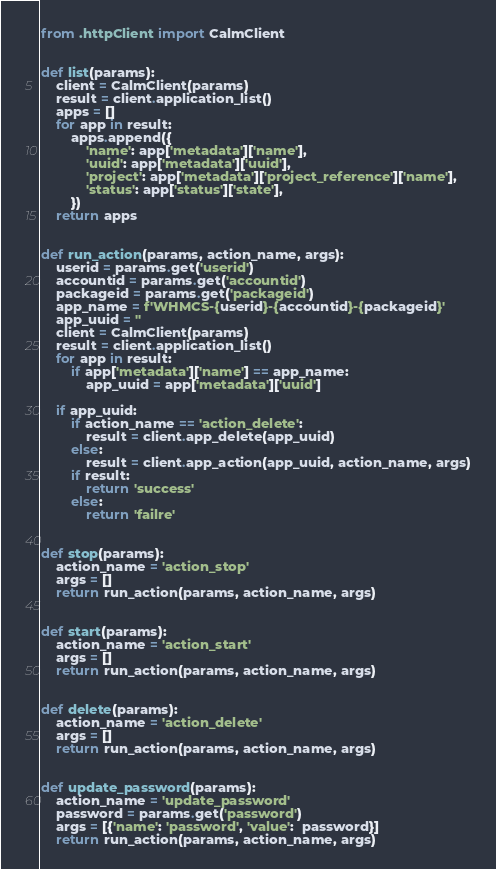<code> <loc_0><loc_0><loc_500><loc_500><_Python_>from .httpClient import CalmClient


def list(params):
    client = CalmClient(params)
    result = client.application_list()
    apps = []
    for app in result:
        apps.append({
            'name': app['metadata']['name'],
            'uuid': app['metadata']['uuid'],
            'project': app['metadata']['project_reference']['name'],
            'status': app['status']['state'],
        })
    return apps


def run_action(params, action_name, args):
    userid = params.get('userid')
    accountid = params.get('accountid')
    packageid = params.get('packageid')
    app_name = f'WHMCS-{userid}-{accountid}-{packageid}'
    app_uuid = ''
    client = CalmClient(params)
    result = client.application_list()
    for app in result:
        if app['metadata']['name'] == app_name:
            app_uuid = app['metadata']['uuid']

    if app_uuid:
        if action_name == 'action_delete':
            result = client.app_delete(app_uuid)
        else:
            result = client.app_action(app_uuid, action_name, args)
        if result:
            return 'success'
        else:
            return 'failre'


def stop(params):
    action_name = 'action_stop'
    args = []
    return run_action(params, action_name, args)


def start(params):
    action_name = 'action_start'
    args = []
    return run_action(params, action_name, args)


def delete(params):
    action_name = 'action_delete'
    args = []
    return run_action(params, action_name, args)


def update_password(params):
    action_name = 'update_password'
    password = params.get('password')
    args = [{'name': 'password', 'value':  password}]
    return run_action(params, action_name, args)


</code> 